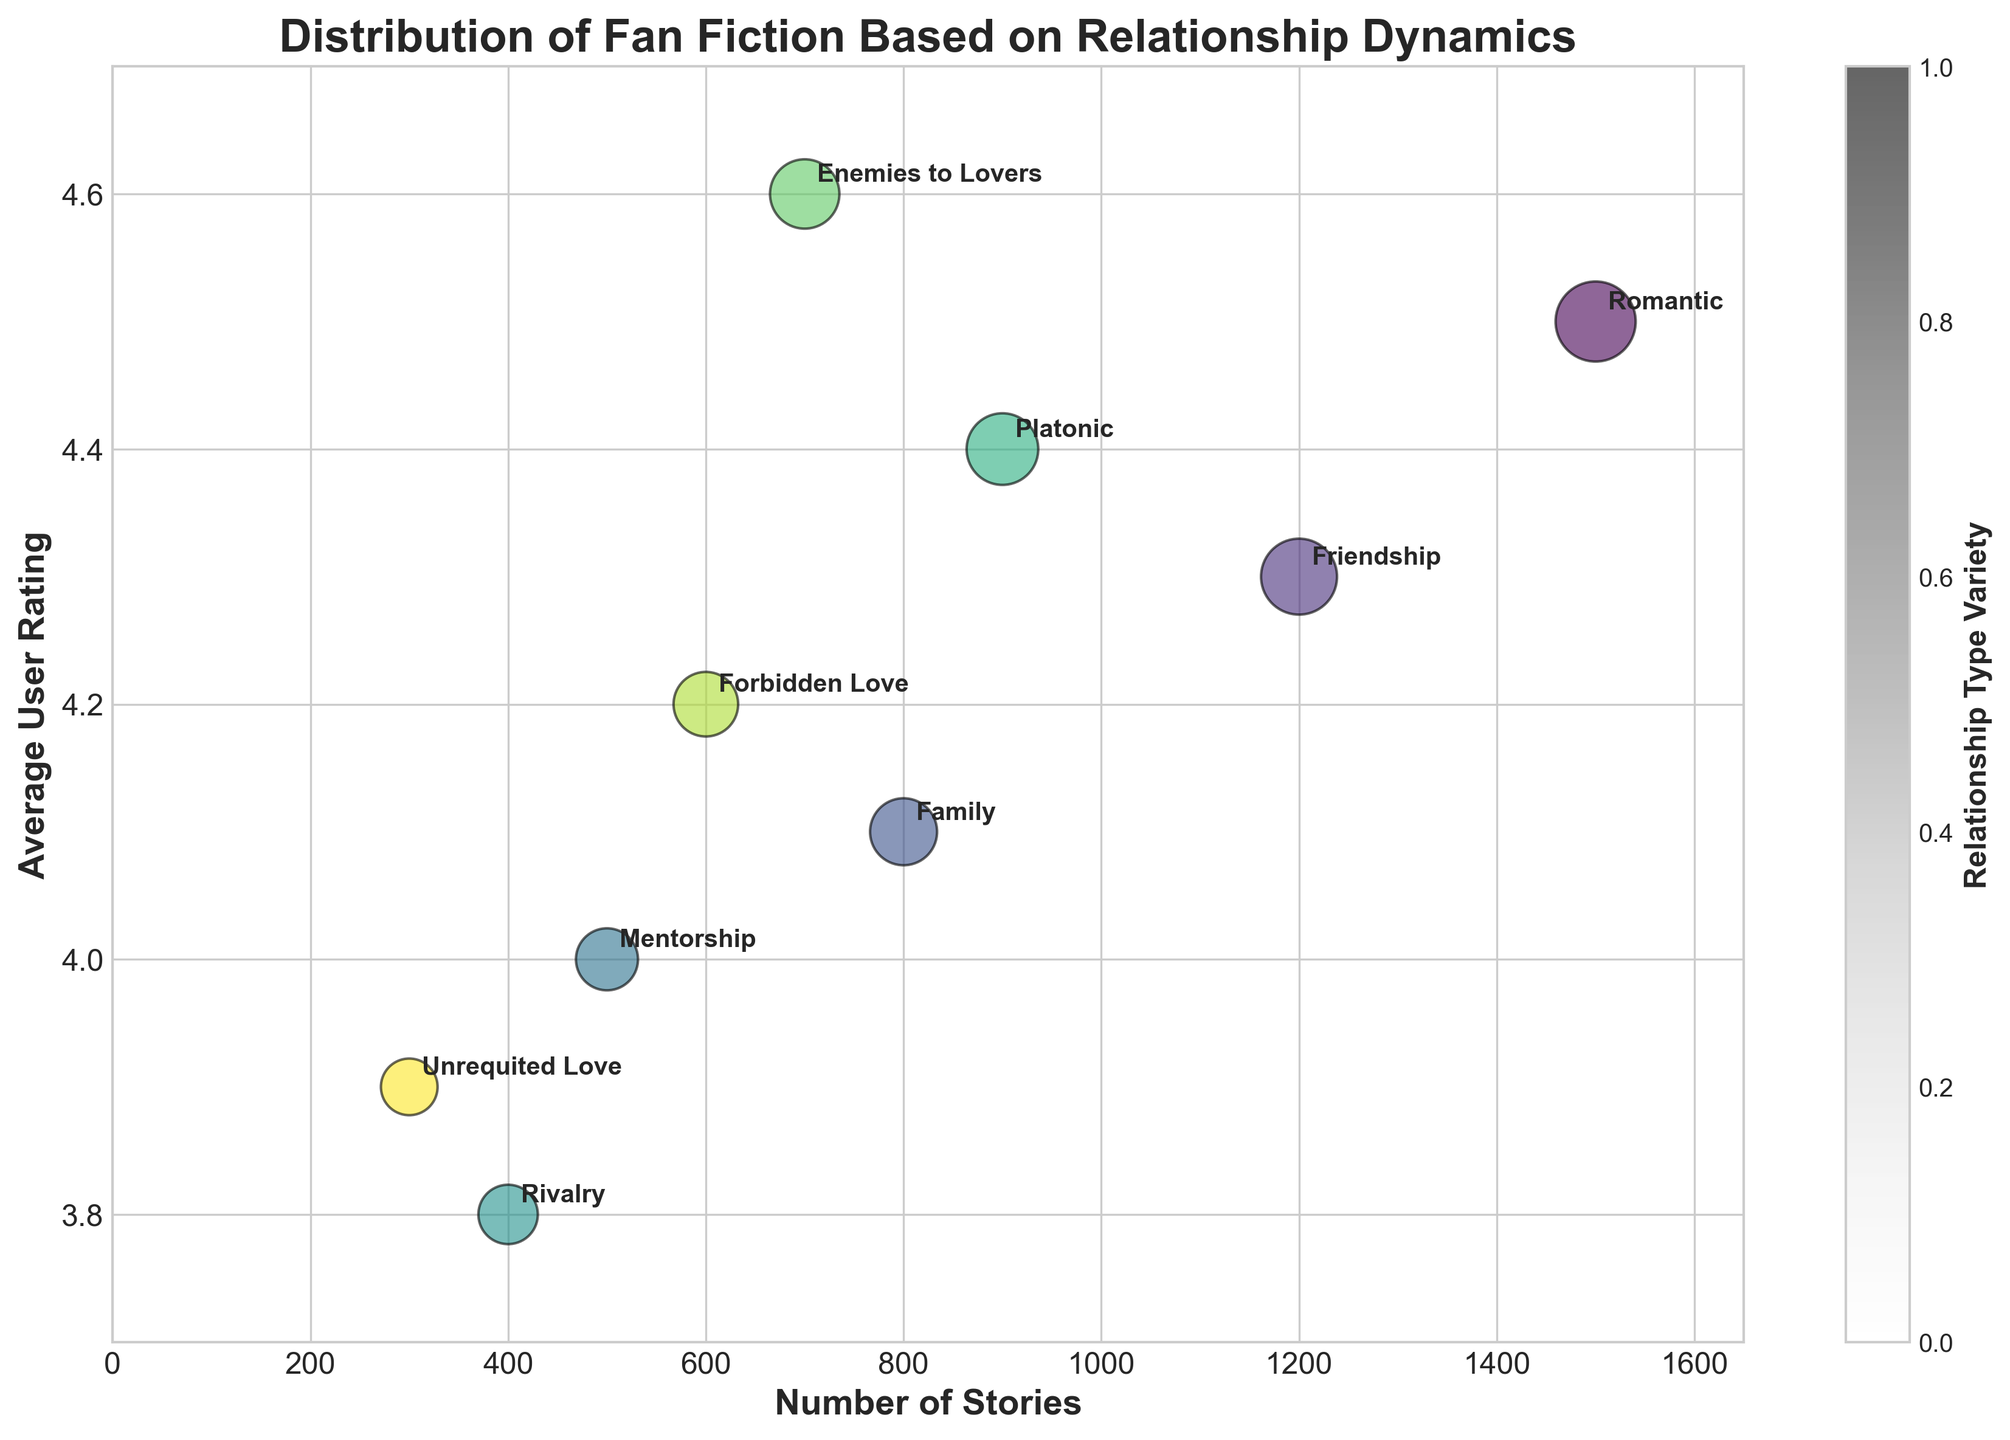What's the title of the figure? The title of the figure can be found at the top of the plot, in a larger and bold font style. It is meant to describe the subject of the plot.
Answer: Distribution of Fan Fiction Based on Relationship Dynamics How many relationship types have been represented in the figure? The number of relationship types can be counted by looking at the number of bubbles or unique labels annotated in the figure.
Answer: 9 Which relationship type has the highest average user rating? By examining the y-axis and finding the bubble located highest up, we see the relationship type labeled there.
Answer: Enemies to Lovers What is the bubble size associated with the "Romantic" relationship type? The bubble size can be identified by looking at the bubble labeled "Romantic." The size usually corresponds to the value provided in the data table under "Bubble Size."
Answer: 200 What's the average user rating for the "Friendship" relationship type? This can be found by locating the bubble with the "Friendship" label and looking vertically aligned to the y-axis value.
Answer: 4.3 Which relationship type has the smallest number of stories? By examining the x-axis and finding the bubble positioned closest to the origin (0, 0) regarding the x-axis, we see the relationship type labeled there.
Answer: Unrequited Love What is the difference in average user ratings between the "Romantic" and "Rivalry" relationship types? Find the y-axis values for both "Romantic" and "Rivalry" labels, then subtract the rating of "Rivalry" from "Romantic."
Answer: 0.7 What relationship type has the second largest bubble size and how many stories does it have? Identify the second biggest bubble by visual inspection and read its label. Then, find the number of stories associated with that label.
Answer: Friendship, 1200 Which two relationship types have the closest average user ratings, and what are those ratings? By closely examining the y-axis positions and comparing how close the bubbles are vertically, identify the two labels that are closest.
Answer: Family and Forbidden Love, 4.1 and 4.2 If you sum up the number of stories for "Enemies to Lovers" and "Unrequited Love," what is the total? Add the number of stories for both "Enemies to Lovers" and "Unrequited Love" based on the x-axis values provided for each.
Answer: 1000 